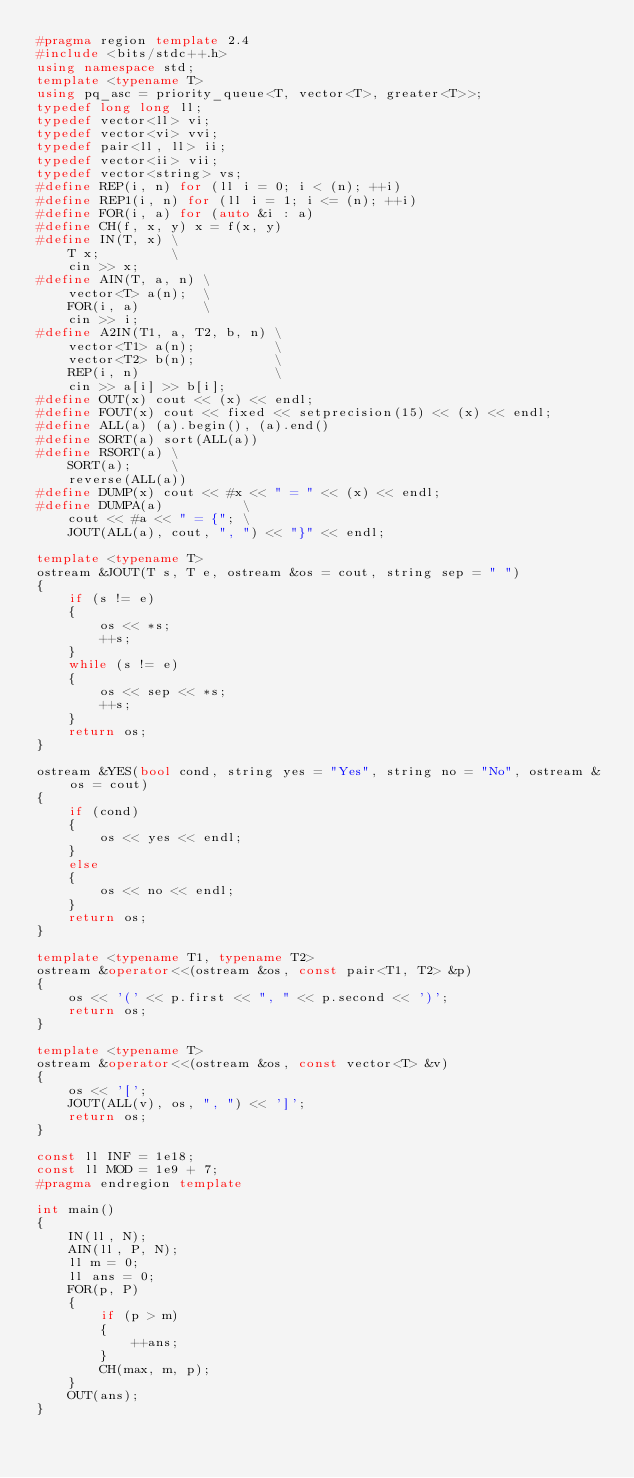<code> <loc_0><loc_0><loc_500><loc_500><_C++_>#pragma region template 2.4
#include <bits/stdc++.h>
using namespace std;
template <typename T>
using pq_asc = priority_queue<T, vector<T>, greater<T>>;
typedef long long ll;
typedef vector<ll> vi;
typedef vector<vi> vvi;
typedef pair<ll, ll> ii;
typedef vector<ii> vii;
typedef vector<string> vs;
#define REP(i, n) for (ll i = 0; i < (n); ++i)
#define REP1(i, n) for (ll i = 1; i <= (n); ++i)
#define FOR(i, a) for (auto &i : a)
#define CH(f, x, y) x = f(x, y)
#define IN(T, x) \
    T x;         \
    cin >> x;
#define AIN(T, a, n) \
    vector<T> a(n);  \
    FOR(i, a)        \
    cin >> i;
#define A2IN(T1, a, T2, b, n) \
    vector<T1> a(n);          \
    vector<T2> b(n);          \
    REP(i, n)                 \
    cin >> a[i] >> b[i];
#define OUT(x) cout << (x) << endl;
#define FOUT(x) cout << fixed << setprecision(15) << (x) << endl;
#define ALL(a) (a).begin(), (a).end()
#define SORT(a) sort(ALL(a))
#define RSORT(a) \
    SORT(a);     \
    reverse(ALL(a))
#define DUMP(x) cout << #x << " = " << (x) << endl;
#define DUMPA(a)          \
    cout << #a << " = {"; \
    JOUT(ALL(a), cout, ", ") << "}" << endl;

template <typename T>
ostream &JOUT(T s, T e, ostream &os = cout, string sep = " ")
{
    if (s != e)
    {
        os << *s;
        ++s;
    }
    while (s != e)
    {
        os << sep << *s;
        ++s;
    }
    return os;
}

ostream &YES(bool cond, string yes = "Yes", string no = "No", ostream &os = cout)
{
    if (cond)
    {
        os << yes << endl;
    }
    else
    {
        os << no << endl;
    }
    return os;
}

template <typename T1, typename T2>
ostream &operator<<(ostream &os, const pair<T1, T2> &p)
{
    os << '(' << p.first << ", " << p.second << ')';
    return os;
}

template <typename T>
ostream &operator<<(ostream &os, const vector<T> &v)
{
    os << '[';
    JOUT(ALL(v), os, ", ") << ']';
    return os;
}

const ll INF = 1e18;
const ll MOD = 1e9 + 7;
#pragma endregion template

int main()
{
    IN(ll, N);
    AIN(ll, P, N);
    ll m = 0;
    ll ans = 0;
    FOR(p, P)
    {
        if (p > m)
        {
            ++ans;
        }
        CH(max, m, p);
    }
    OUT(ans);
}</code> 